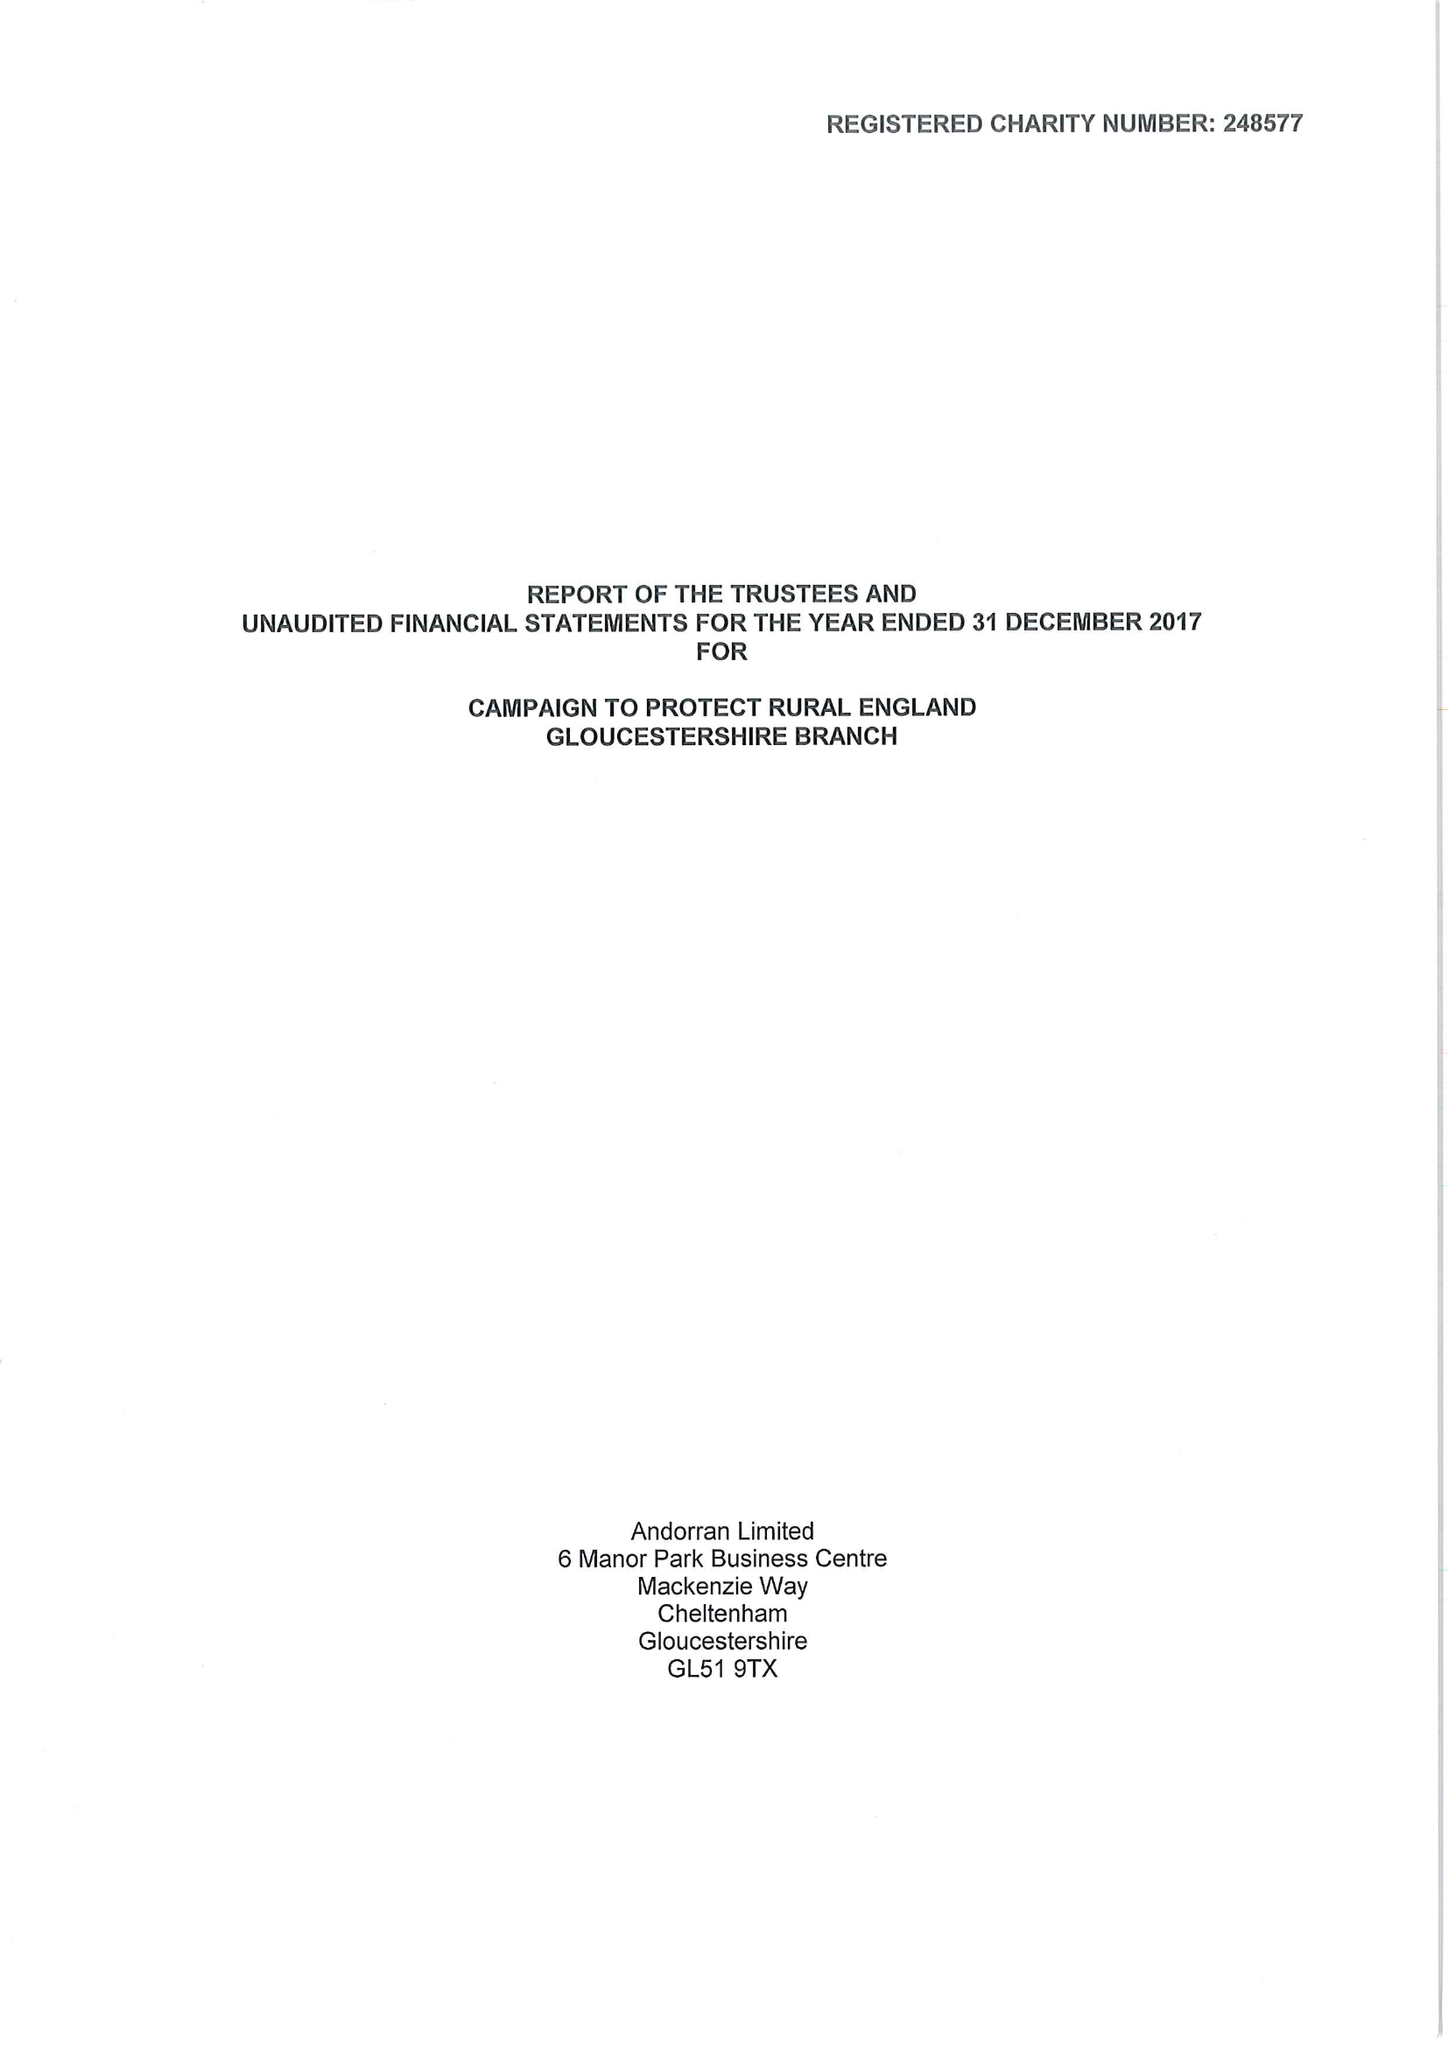What is the value for the charity_number?
Answer the question using a single word or phrase. 248577 